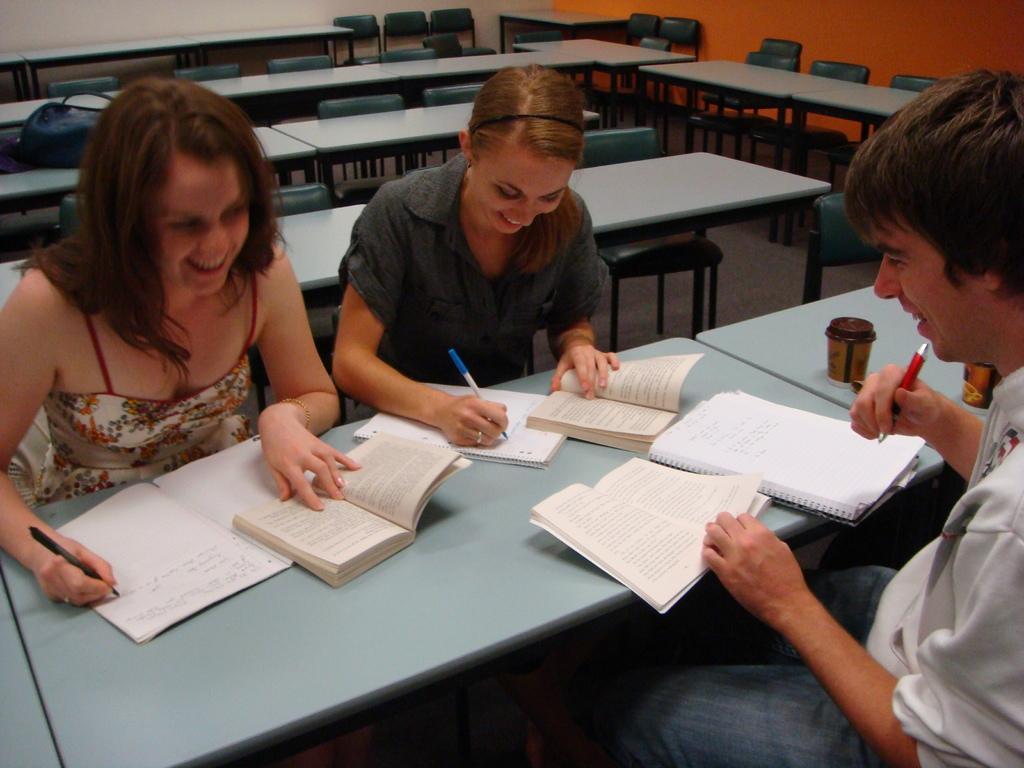Could you give a brief overview of what you see in this image? In this image we can see tables and chairs. On the table there are books. Also we can see three persons holding pens. Also there are glasses on the table. 